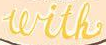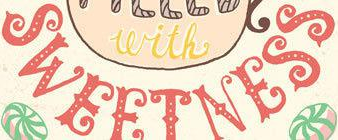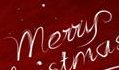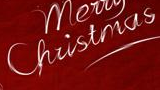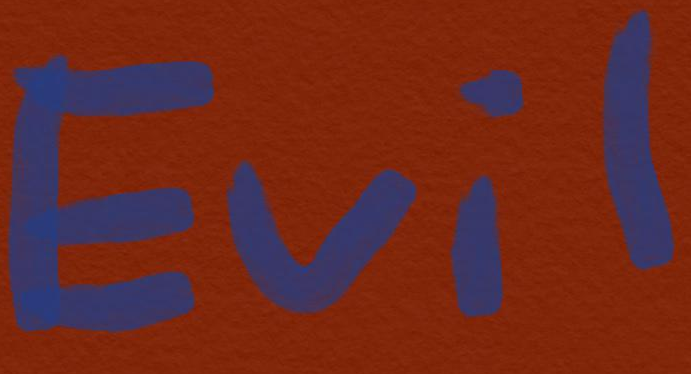What text appears in these images from left to right, separated by a semicolon? with; SWEETNESS; Merry; Christmas; Evil 